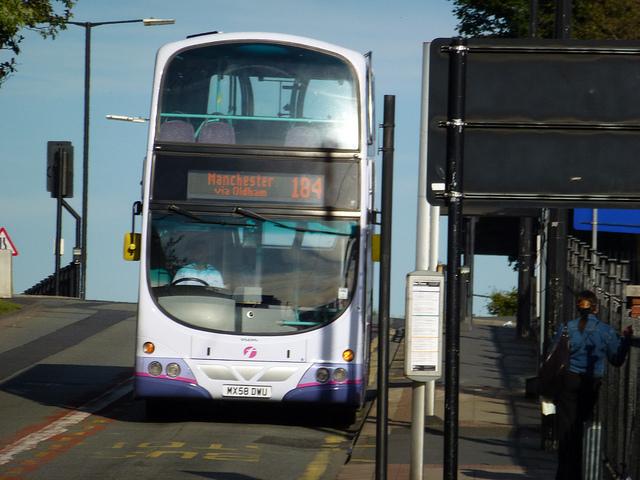How many levels does this bus have?
Short answer required. 2. Would this bus take you to Manchester?
Short answer required. Yes. Is this a school bus?
Concise answer only. No. 